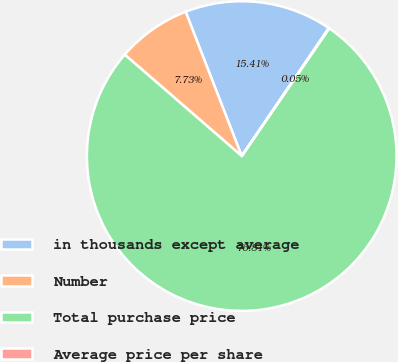Convert chart to OTSL. <chart><loc_0><loc_0><loc_500><loc_500><pie_chart><fcel>in thousands except average<fcel>Number<fcel>Total purchase price<fcel>Average price per share<nl><fcel>15.41%<fcel>7.73%<fcel>76.81%<fcel>0.05%<nl></chart> 